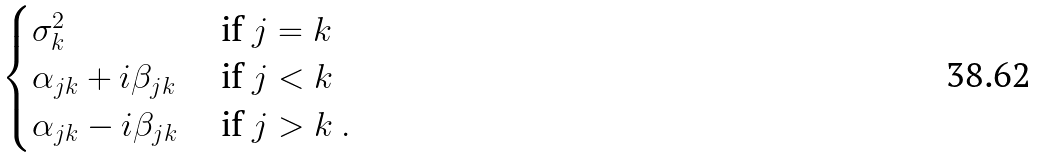<formula> <loc_0><loc_0><loc_500><loc_500>\begin{cases} \sigma _ { k } ^ { 2 } & \text { if } j = k \\ \alpha _ { j k } + i \beta _ { j k } & \text { if } j < k \\ \alpha _ { j k } - i \beta _ { j k } & \text { if } j > k \ . \end{cases}</formula> 